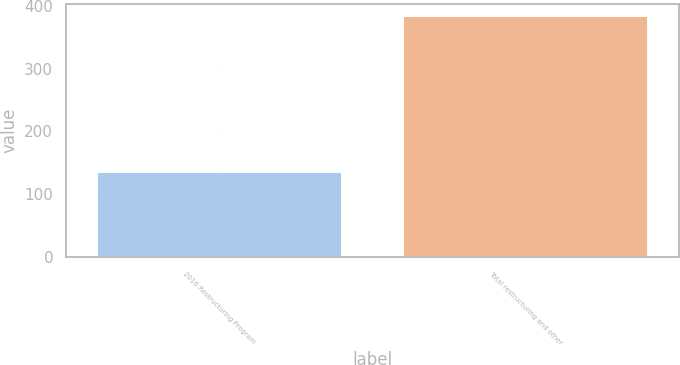Convert chart. <chart><loc_0><loc_0><loc_500><loc_500><bar_chart><fcel>2016 Restructuring Program<fcel>Total restructuring and other<nl><fcel>135<fcel>384<nl></chart> 